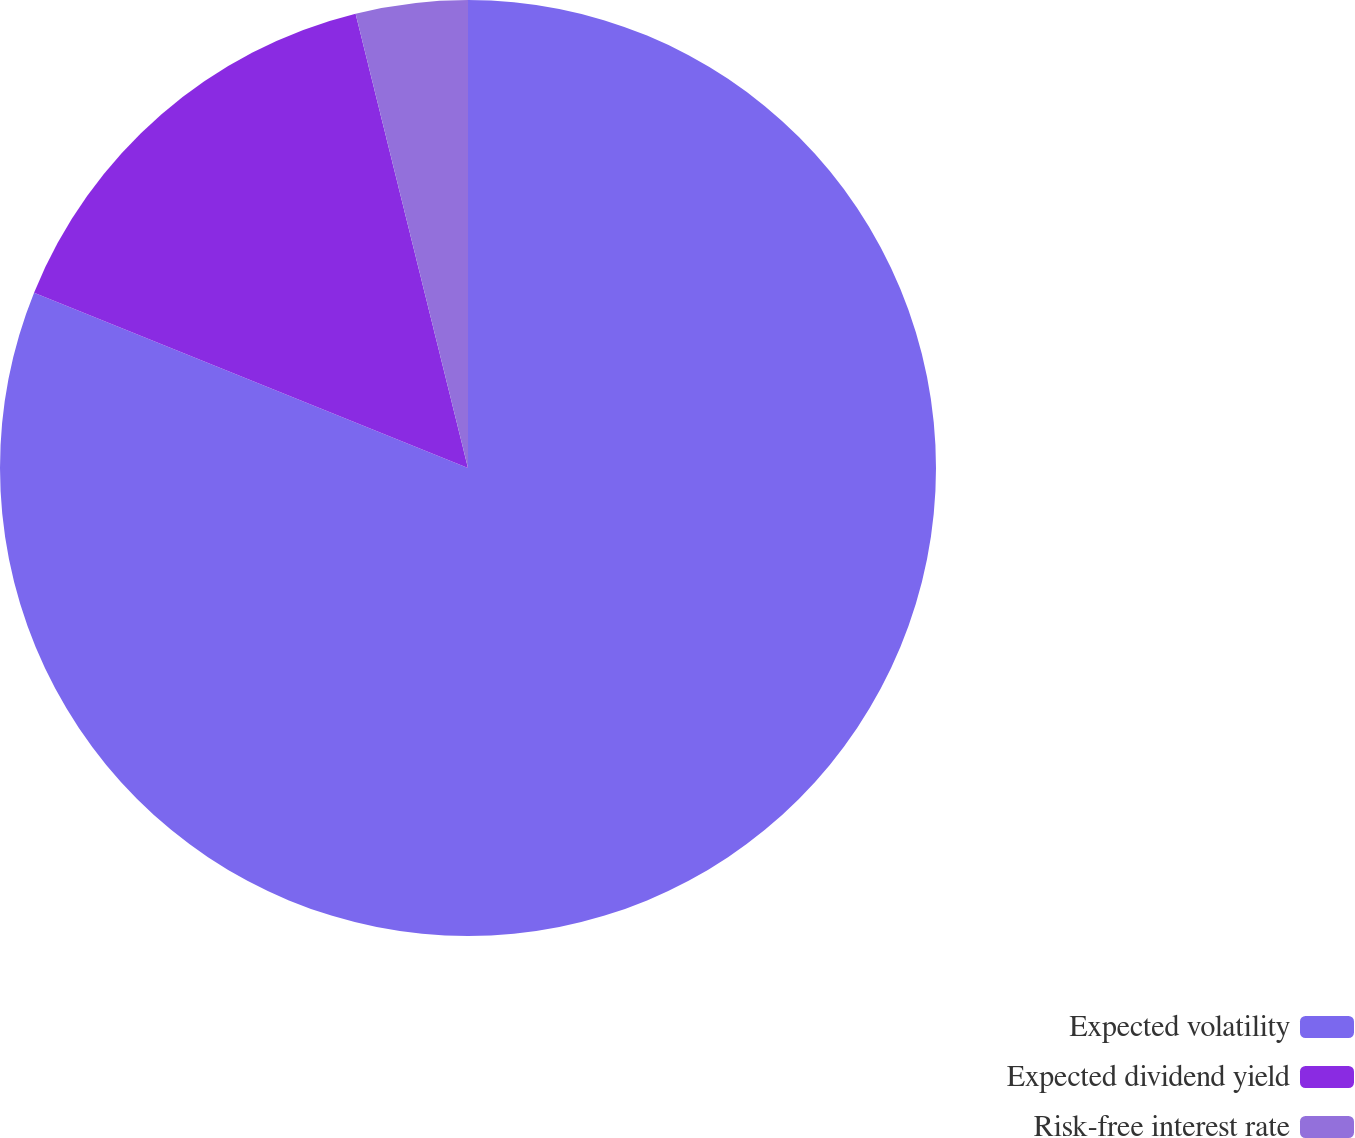<chart> <loc_0><loc_0><loc_500><loc_500><pie_chart><fcel>Expected volatility<fcel>Expected dividend yield<fcel>Risk-free interest rate<nl><fcel>81.11%<fcel>15.03%<fcel>3.86%<nl></chart> 